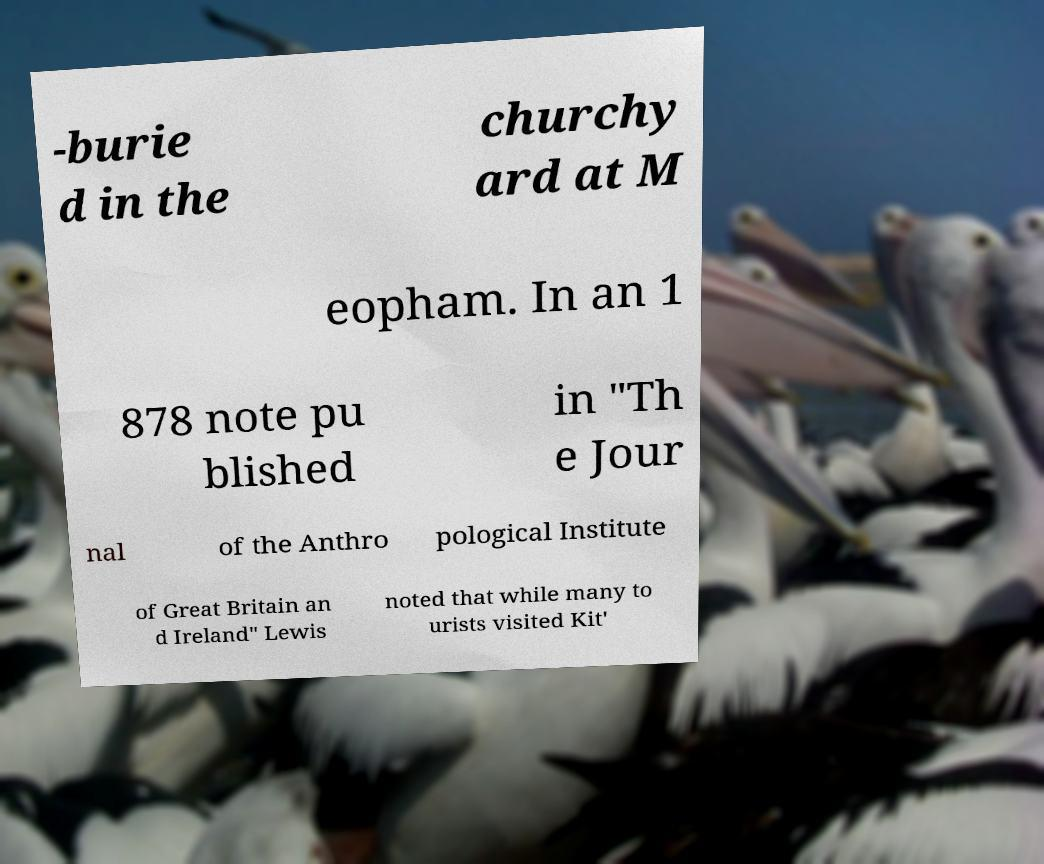What messages or text are displayed in this image? I need them in a readable, typed format. -burie d in the churchy ard at M eopham. In an 1 878 note pu blished in "Th e Jour nal of the Anthro pological Institute of Great Britain an d Ireland" Lewis noted that while many to urists visited Kit' 